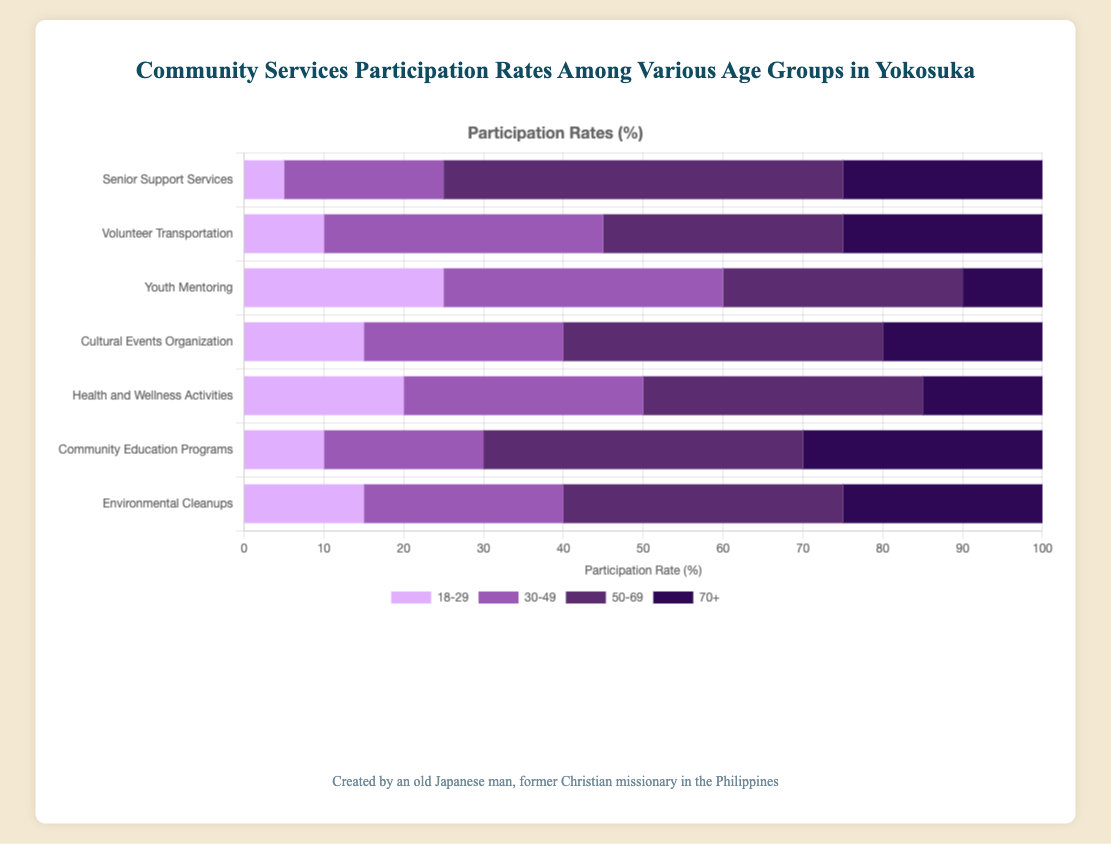What service do people aged 50-69 participate in the most? The bar for the 50-69 age group in "Senior Support Services" reaches 50, which is the highest participation rate among all services for this age group.
Answer: Senior Support Services Which age group has the highest participation in Environmental Cleanups? The 50-69 age group's bar for Environmental Cleanups reaches 35, which is the highest among the age groups for this service.
Answer: 50-69 For the Youth Mentoring service, how much greater is the participation rate for the 30-49 age group compared to the 70+ age group? The participation rate for the 30-49 age group is 35 and for the 70+ age group is 10. The difference is 35 - 10 = 25.
Answer: 25 What is the total participation rate for the 18-29 age group across all services? Sum the participation rates for the 18-29 age group across all services: 15 + 10 + 20 + 15 + 25 + 5 + 10 = 100.
Answer: 100 Compare the participation rates of Cultural Events Organization for the age groups 18-29 and 50-69. Which is higher and by how much? The participation rate for the 18-29 age group is 15, and for the 50-69 age group is 40. The 50-69 participation rate is higher by 40 - 15 = 25.
Answer: 50-69, 25 Identify the service where the age group 70+ has the lowest participation. The 70+ participation rate is lowest in Youth Mentoring with a rate of 10, as indicated by the shortest bar in that category.
Answer: Youth Mentoring What is the average participation rate for Health and Wellness Activities across all age groups? The rates are 20 (18-29), 30 (30-49), 35 (50-69), and 15 (70+). The average is (20 + 30 + 35 + 15) / 4 = 100 / 4 = 25.
Answer: 25 How does the participation rate for the 18-29 age group in Volunteer Transportation compare to that in Senior Support Services? The participation rate for Volunteer Transportation is 10 and for Senior Support Services is 5. The rate for Volunteer Transportation is higher by 10 - 5 = 5.
Answer: 5 Calculate the total participation rate for the service Community Education Programs across all age groups. Sum the rates: 10 (18-29) + 20 (30-49) + 40 (50-69) + 30 (70+) = 100.
Answer: 100 